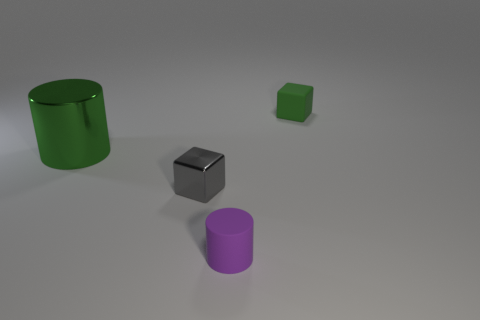How many matte objects are the same color as the rubber cylinder?
Offer a very short reply. 0. There is a green thing that is right of the tiny block left of the cylinder that is to the right of the green metallic object; what size is it?
Your answer should be very brief. Small. How many rubber things are large green cylinders or tiny purple objects?
Your response must be concise. 1. There is a tiny gray object; is it the same shape as the small matte thing that is behind the matte cylinder?
Ensure brevity in your answer.  Yes. Are there more tiny rubber cylinders behind the big thing than small gray metal cubes in front of the purple matte object?
Make the answer very short. No. Is there anything else that has the same color as the small rubber cylinder?
Make the answer very short. No. There is a cylinder on the left side of the tiny matte thing in front of the big cylinder; are there any green rubber cubes that are in front of it?
Your answer should be very brief. No. There is a small object to the right of the purple cylinder; is it the same shape as the large object?
Your answer should be compact. No. Are there fewer green cylinders right of the tiny purple thing than rubber objects to the right of the tiny green thing?
Your answer should be compact. No. What material is the gray object?
Offer a very short reply. Metal. 